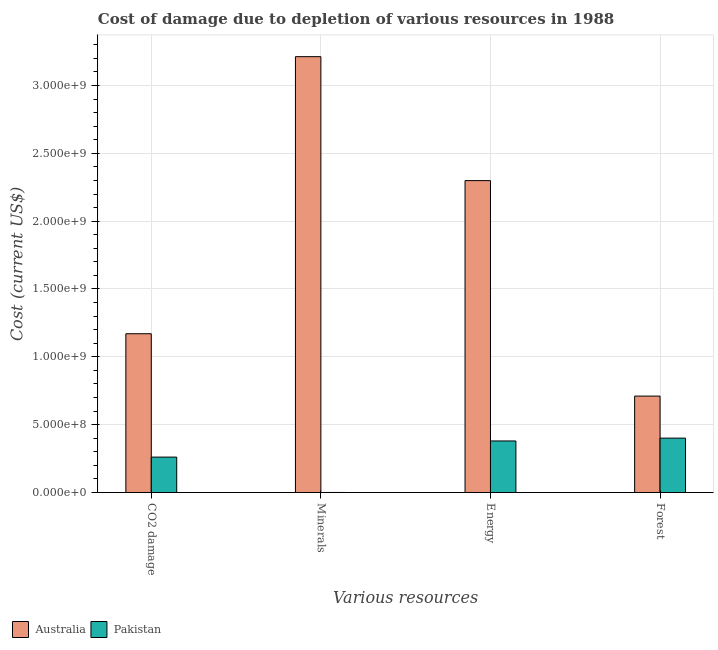How many groups of bars are there?
Your answer should be very brief. 4. How many bars are there on the 3rd tick from the right?
Give a very brief answer. 2. What is the label of the 2nd group of bars from the left?
Make the answer very short. Minerals. What is the cost of damage due to depletion of energy in Pakistan?
Keep it short and to the point. 3.80e+08. Across all countries, what is the maximum cost of damage due to depletion of forests?
Your answer should be very brief. 7.11e+08. Across all countries, what is the minimum cost of damage due to depletion of forests?
Ensure brevity in your answer.  4.01e+08. In which country was the cost of damage due to depletion of forests maximum?
Provide a succinct answer. Australia. In which country was the cost of damage due to depletion of forests minimum?
Offer a very short reply. Pakistan. What is the total cost of damage due to depletion of forests in the graph?
Offer a terse response. 1.11e+09. What is the difference between the cost of damage due to depletion of coal in Pakistan and that in Australia?
Your answer should be very brief. -9.09e+08. What is the difference between the cost of damage due to depletion of coal in Australia and the cost of damage due to depletion of energy in Pakistan?
Provide a short and direct response. 7.90e+08. What is the average cost of damage due to depletion of minerals per country?
Your answer should be compact. 1.61e+09. What is the difference between the cost of damage due to depletion of energy and cost of damage due to depletion of forests in Pakistan?
Your answer should be very brief. -2.08e+07. In how many countries, is the cost of damage due to depletion of energy greater than 400000000 US$?
Give a very brief answer. 1. What is the ratio of the cost of damage due to depletion of energy in Pakistan to that in Australia?
Provide a succinct answer. 0.17. Is the cost of damage due to depletion of energy in Australia less than that in Pakistan?
Offer a terse response. No. What is the difference between the highest and the second highest cost of damage due to depletion of coal?
Your answer should be very brief. 9.09e+08. What is the difference between the highest and the lowest cost of damage due to depletion of forests?
Provide a succinct answer. 3.10e+08. In how many countries, is the cost of damage due to depletion of energy greater than the average cost of damage due to depletion of energy taken over all countries?
Offer a terse response. 1. Is the sum of the cost of damage due to depletion of energy in Pakistan and Australia greater than the maximum cost of damage due to depletion of forests across all countries?
Provide a succinct answer. Yes. What does the 2nd bar from the left in CO2 damage represents?
Provide a short and direct response. Pakistan. How many countries are there in the graph?
Your answer should be compact. 2. What is the difference between two consecutive major ticks on the Y-axis?
Provide a short and direct response. 5.00e+08. Are the values on the major ticks of Y-axis written in scientific E-notation?
Keep it short and to the point. Yes. Does the graph contain any zero values?
Provide a short and direct response. No. Where does the legend appear in the graph?
Offer a very short reply. Bottom left. How many legend labels are there?
Your answer should be very brief. 2. How are the legend labels stacked?
Give a very brief answer. Horizontal. What is the title of the graph?
Your answer should be very brief. Cost of damage due to depletion of various resources in 1988 . Does "New Zealand" appear as one of the legend labels in the graph?
Give a very brief answer. No. What is the label or title of the X-axis?
Provide a short and direct response. Various resources. What is the label or title of the Y-axis?
Give a very brief answer. Cost (current US$). What is the Cost (current US$) in Australia in CO2 damage?
Keep it short and to the point. 1.17e+09. What is the Cost (current US$) of Pakistan in CO2 damage?
Offer a terse response. 2.61e+08. What is the Cost (current US$) in Australia in Minerals?
Keep it short and to the point. 3.21e+09. What is the Cost (current US$) of Pakistan in Minerals?
Provide a short and direct response. 2.79e+04. What is the Cost (current US$) in Australia in Energy?
Give a very brief answer. 2.30e+09. What is the Cost (current US$) in Pakistan in Energy?
Offer a terse response. 3.80e+08. What is the Cost (current US$) in Australia in Forest?
Offer a very short reply. 7.11e+08. What is the Cost (current US$) in Pakistan in Forest?
Provide a succinct answer. 4.01e+08. Across all Various resources, what is the maximum Cost (current US$) of Australia?
Give a very brief answer. 3.21e+09. Across all Various resources, what is the maximum Cost (current US$) in Pakistan?
Ensure brevity in your answer.  4.01e+08. Across all Various resources, what is the minimum Cost (current US$) of Australia?
Your response must be concise. 7.11e+08. Across all Various resources, what is the minimum Cost (current US$) in Pakistan?
Give a very brief answer. 2.79e+04. What is the total Cost (current US$) in Australia in the graph?
Give a very brief answer. 7.39e+09. What is the total Cost (current US$) of Pakistan in the graph?
Offer a terse response. 1.04e+09. What is the difference between the Cost (current US$) in Australia in CO2 damage and that in Minerals?
Make the answer very short. -2.04e+09. What is the difference between the Cost (current US$) of Pakistan in CO2 damage and that in Minerals?
Give a very brief answer. 2.61e+08. What is the difference between the Cost (current US$) in Australia in CO2 damage and that in Energy?
Offer a terse response. -1.13e+09. What is the difference between the Cost (current US$) of Pakistan in CO2 damage and that in Energy?
Your answer should be compact. -1.19e+08. What is the difference between the Cost (current US$) of Australia in CO2 damage and that in Forest?
Make the answer very short. 4.60e+08. What is the difference between the Cost (current US$) in Pakistan in CO2 damage and that in Forest?
Your answer should be compact. -1.40e+08. What is the difference between the Cost (current US$) in Australia in Minerals and that in Energy?
Keep it short and to the point. 9.14e+08. What is the difference between the Cost (current US$) in Pakistan in Minerals and that in Energy?
Provide a succinct answer. -3.80e+08. What is the difference between the Cost (current US$) of Australia in Minerals and that in Forest?
Make the answer very short. 2.50e+09. What is the difference between the Cost (current US$) of Pakistan in Minerals and that in Forest?
Provide a succinct answer. -4.01e+08. What is the difference between the Cost (current US$) of Australia in Energy and that in Forest?
Offer a very short reply. 1.59e+09. What is the difference between the Cost (current US$) in Pakistan in Energy and that in Forest?
Your answer should be compact. -2.08e+07. What is the difference between the Cost (current US$) in Australia in CO2 damage and the Cost (current US$) in Pakistan in Minerals?
Offer a terse response. 1.17e+09. What is the difference between the Cost (current US$) in Australia in CO2 damage and the Cost (current US$) in Pakistan in Energy?
Keep it short and to the point. 7.90e+08. What is the difference between the Cost (current US$) of Australia in CO2 damage and the Cost (current US$) of Pakistan in Forest?
Keep it short and to the point. 7.70e+08. What is the difference between the Cost (current US$) in Australia in Minerals and the Cost (current US$) in Pakistan in Energy?
Your answer should be compact. 2.83e+09. What is the difference between the Cost (current US$) in Australia in Minerals and the Cost (current US$) in Pakistan in Forest?
Your answer should be compact. 2.81e+09. What is the difference between the Cost (current US$) of Australia in Energy and the Cost (current US$) of Pakistan in Forest?
Give a very brief answer. 1.90e+09. What is the average Cost (current US$) of Australia per Various resources?
Give a very brief answer. 1.85e+09. What is the average Cost (current US$) of Pakistan per Various resources?
Your answer should be compact. 2.60e+08. What is the difference between the Cost (current US$) in Australia and Cost (current US$) in Pakistan in CO2 damage?
Your response must be concise. 9.09e+08. What is the difference between the Cost (current US$) in Australia and Cost (current US$) in Pakistan in Minerals?
Provide a short and direct response. 3.21e+09. What is the difference between the Cost (current US$) in Australia and Cost (current US$) in Pakistan in Energy?
Ensure brevity in your answer.  1.92e+09. What is the difference between the Cost (current US$) of Australia and Cost (current US$) of Pakistan in Forest?
Provide a short and direct response. 3.10e+08. What is the ratio of the Cost (current US$) in Australia in CO2 damage to that in Minerals?
Provide a short and direct response. 0.36. What is the ratio of the Cost (current US$) in Pakistan in CO2 damage to that in Minerals?
Make the answer very short. 9335.89. What is the ratio of the Cost (current US$) of Australia in CO2 damage to that in Energy?
Keep it short and to the point. 0.51. What is the ratio of the Cost (current US$) of Pakistan in CO2 damage to that in Energy?
Ensure brevity in your answer.  0.69. What is the ratio of the Cost (current US$) in Australia in CO2 damage to that in Forest?
Your answer should be very brief. 1.65. What is the ratio of the Cost (current US$) in Pakistan in CO2 damage to that in Forest?
Ensure brevity in your answer.  0.65. What is the ratio of the Cost (current US$) of Australia in Minerals to that in Energy?
Keep it short and to the point. 1.4. What is the ratio of the Cost (current US$) in Pakistan in Minerals to that in Energy?
Give a very brief answer. 0. What is the ratio of the Cost (current US$) of Australia in Minerals to that in Forest?
Keep it short and to the point. 4.52. What is the ratio of the Cost (current US$) in Australia in Energy to that in Forest?
Ensure brevity in your answer.  3.24. What is the ratio of the Cost (current US$) of Pakistan in Energy to that in Forest?
Your answer should be very brief. 0.95. What is the difference between the highest and the second highest Cost (current US$) of Australia?
Your response must be concise. 9.14e+08. What is the difference between the highest and the second highest Cost (current US$) in Pakistan?
Provide a short and direct response. 2.08e+07. What is the difference between the highest and the lowest Cost (current US$) in Australia?
Provide a succinct answer. 2.50e+09. What is the difference between the highest and the lowest Cost (current US$) in Pakistan?
Offer a very short reply. 4.01e+08. 